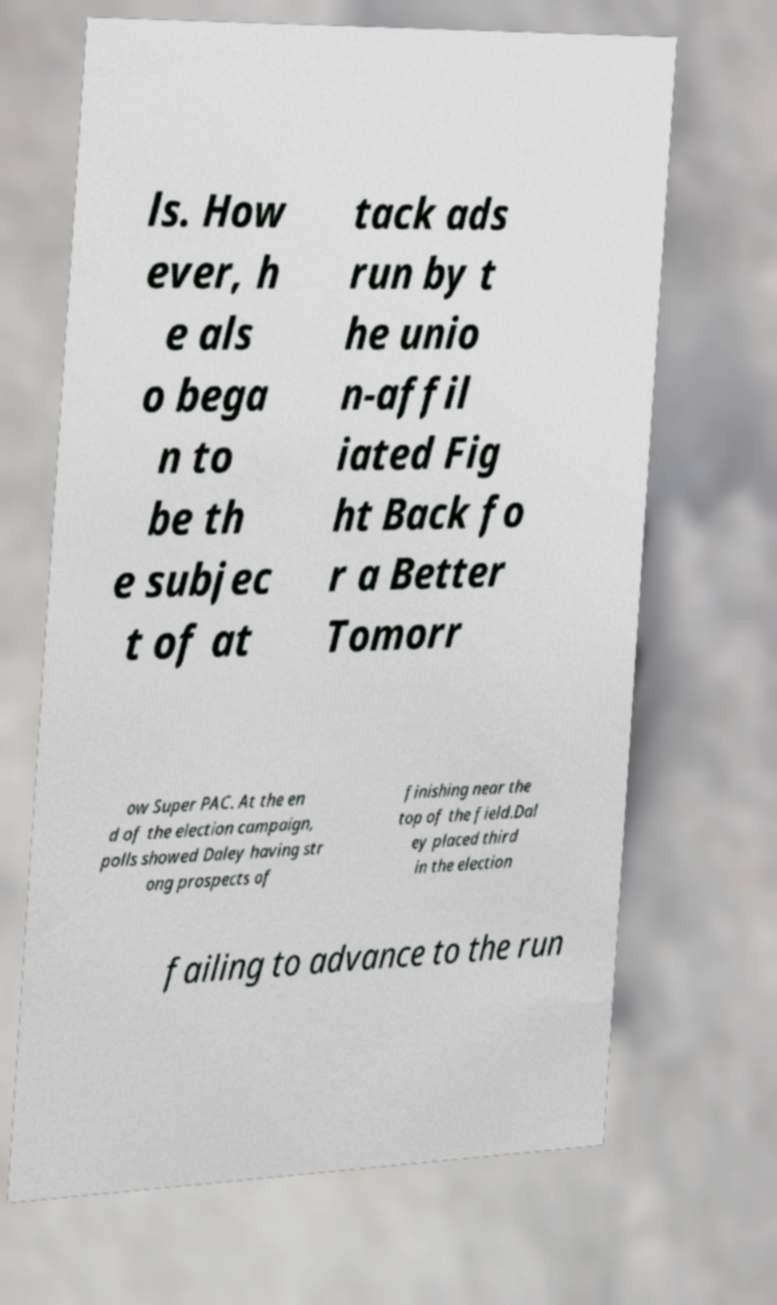What messages or text are displayed in this image? I need them in a readable, typed format. ls. How ever, h e als o bega n to be th e subjec t of at tack ads run by t he unio n-affil iated Fig ht Back fo r a Better Tomorr ow Super PAC. At the en d of the election campaign, polls showed Daley having str ong prospects of finishing near the top of the field.Dal ey placed third in the election failing to advance to the run 